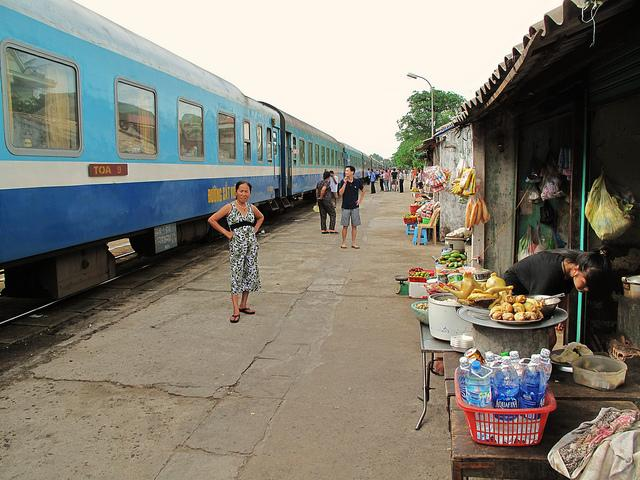What is the person on the right selling?

Choices:
A) pizza
B) water
C) cars
D) swords water 